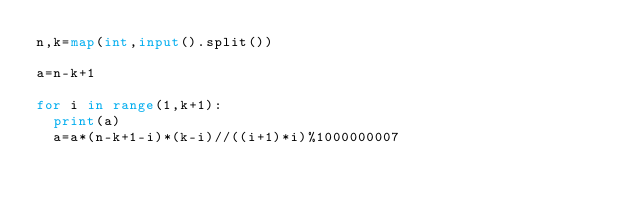Convert code to text. <code><loc_0><loc_0><loc_500><loc_500><_Python_>n,k=map(int,input().split())

a=n-k+1

for i in range(1,k+1):
  print(a)
  a=a*(n-k+1-i)*(k-i)//((i+1)*i)%1000000007
  


</code> 